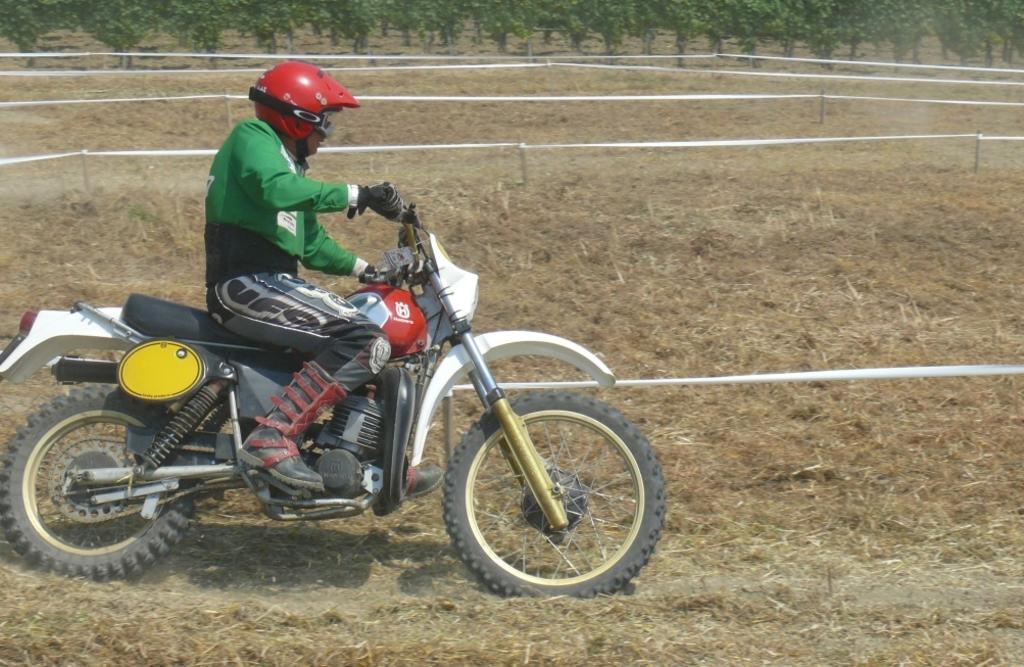Could you give a brief overview of what you see in this image? Bottom left side of the image a man is riding a motorcycle. Behind him there is a fencing and there is grass. Top of the image there are some trees. 